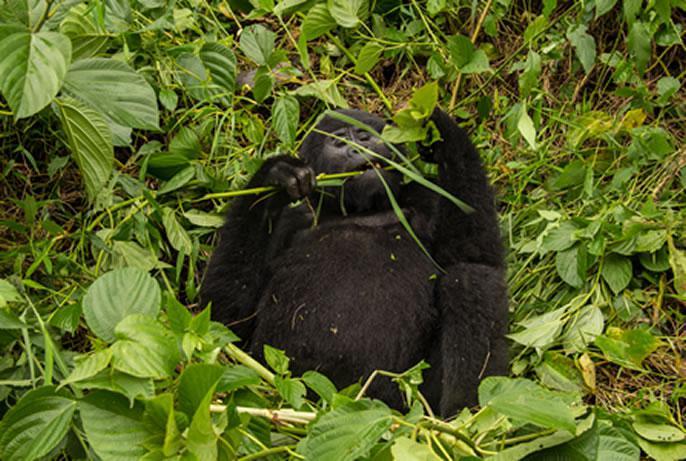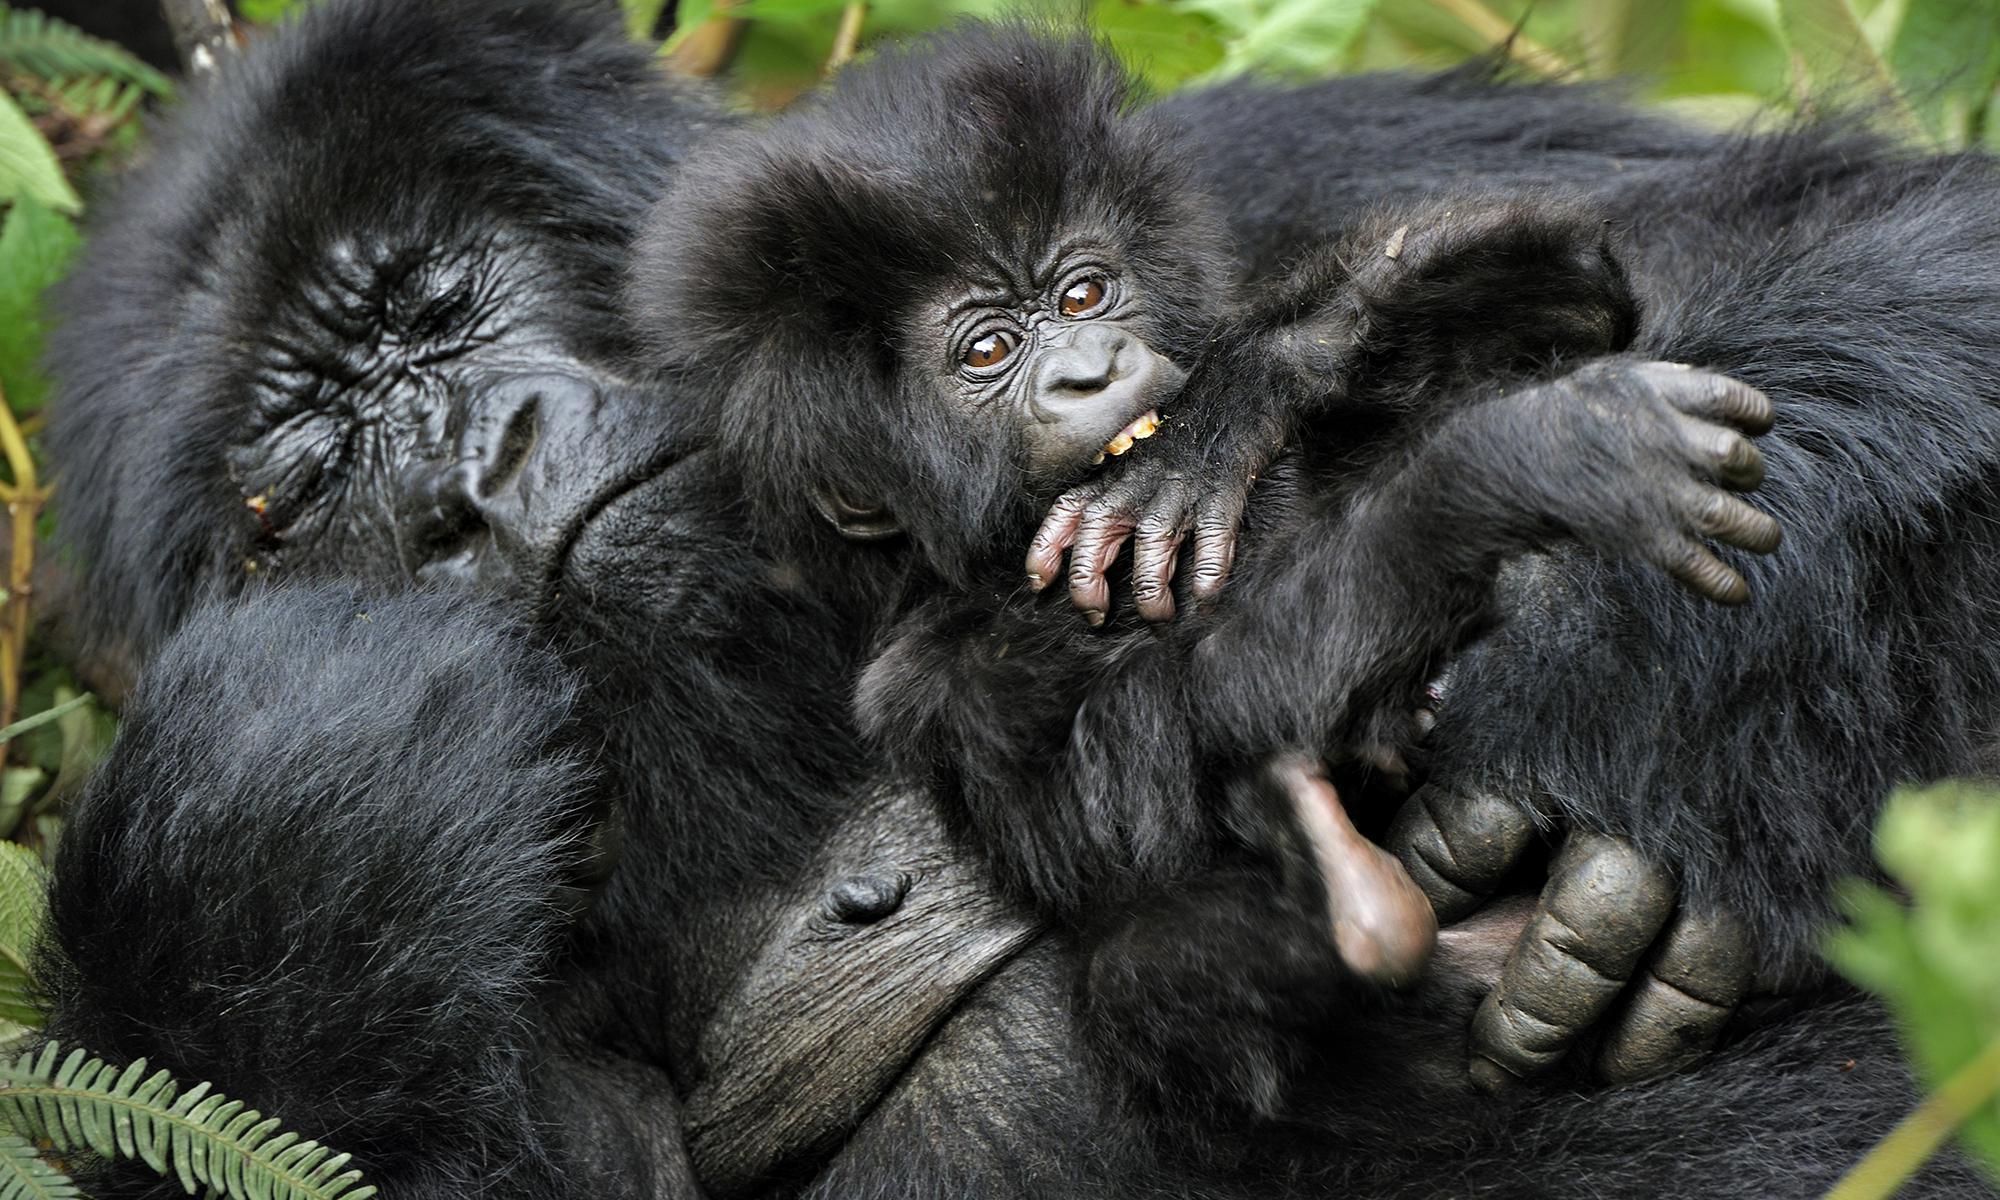The first image is the image on the left, the second image is the image on the right. For the images shown, is this caption "There are two gorillas in the pair of images." true? Answer yes or no. No. The first image is the image on the left, the second image is the image on the right. Assess this claim about the two images: "Each image shows a single gorilla, and all gorillas are in a reclining pose.". Correct or not? Answer yes or no. No. 